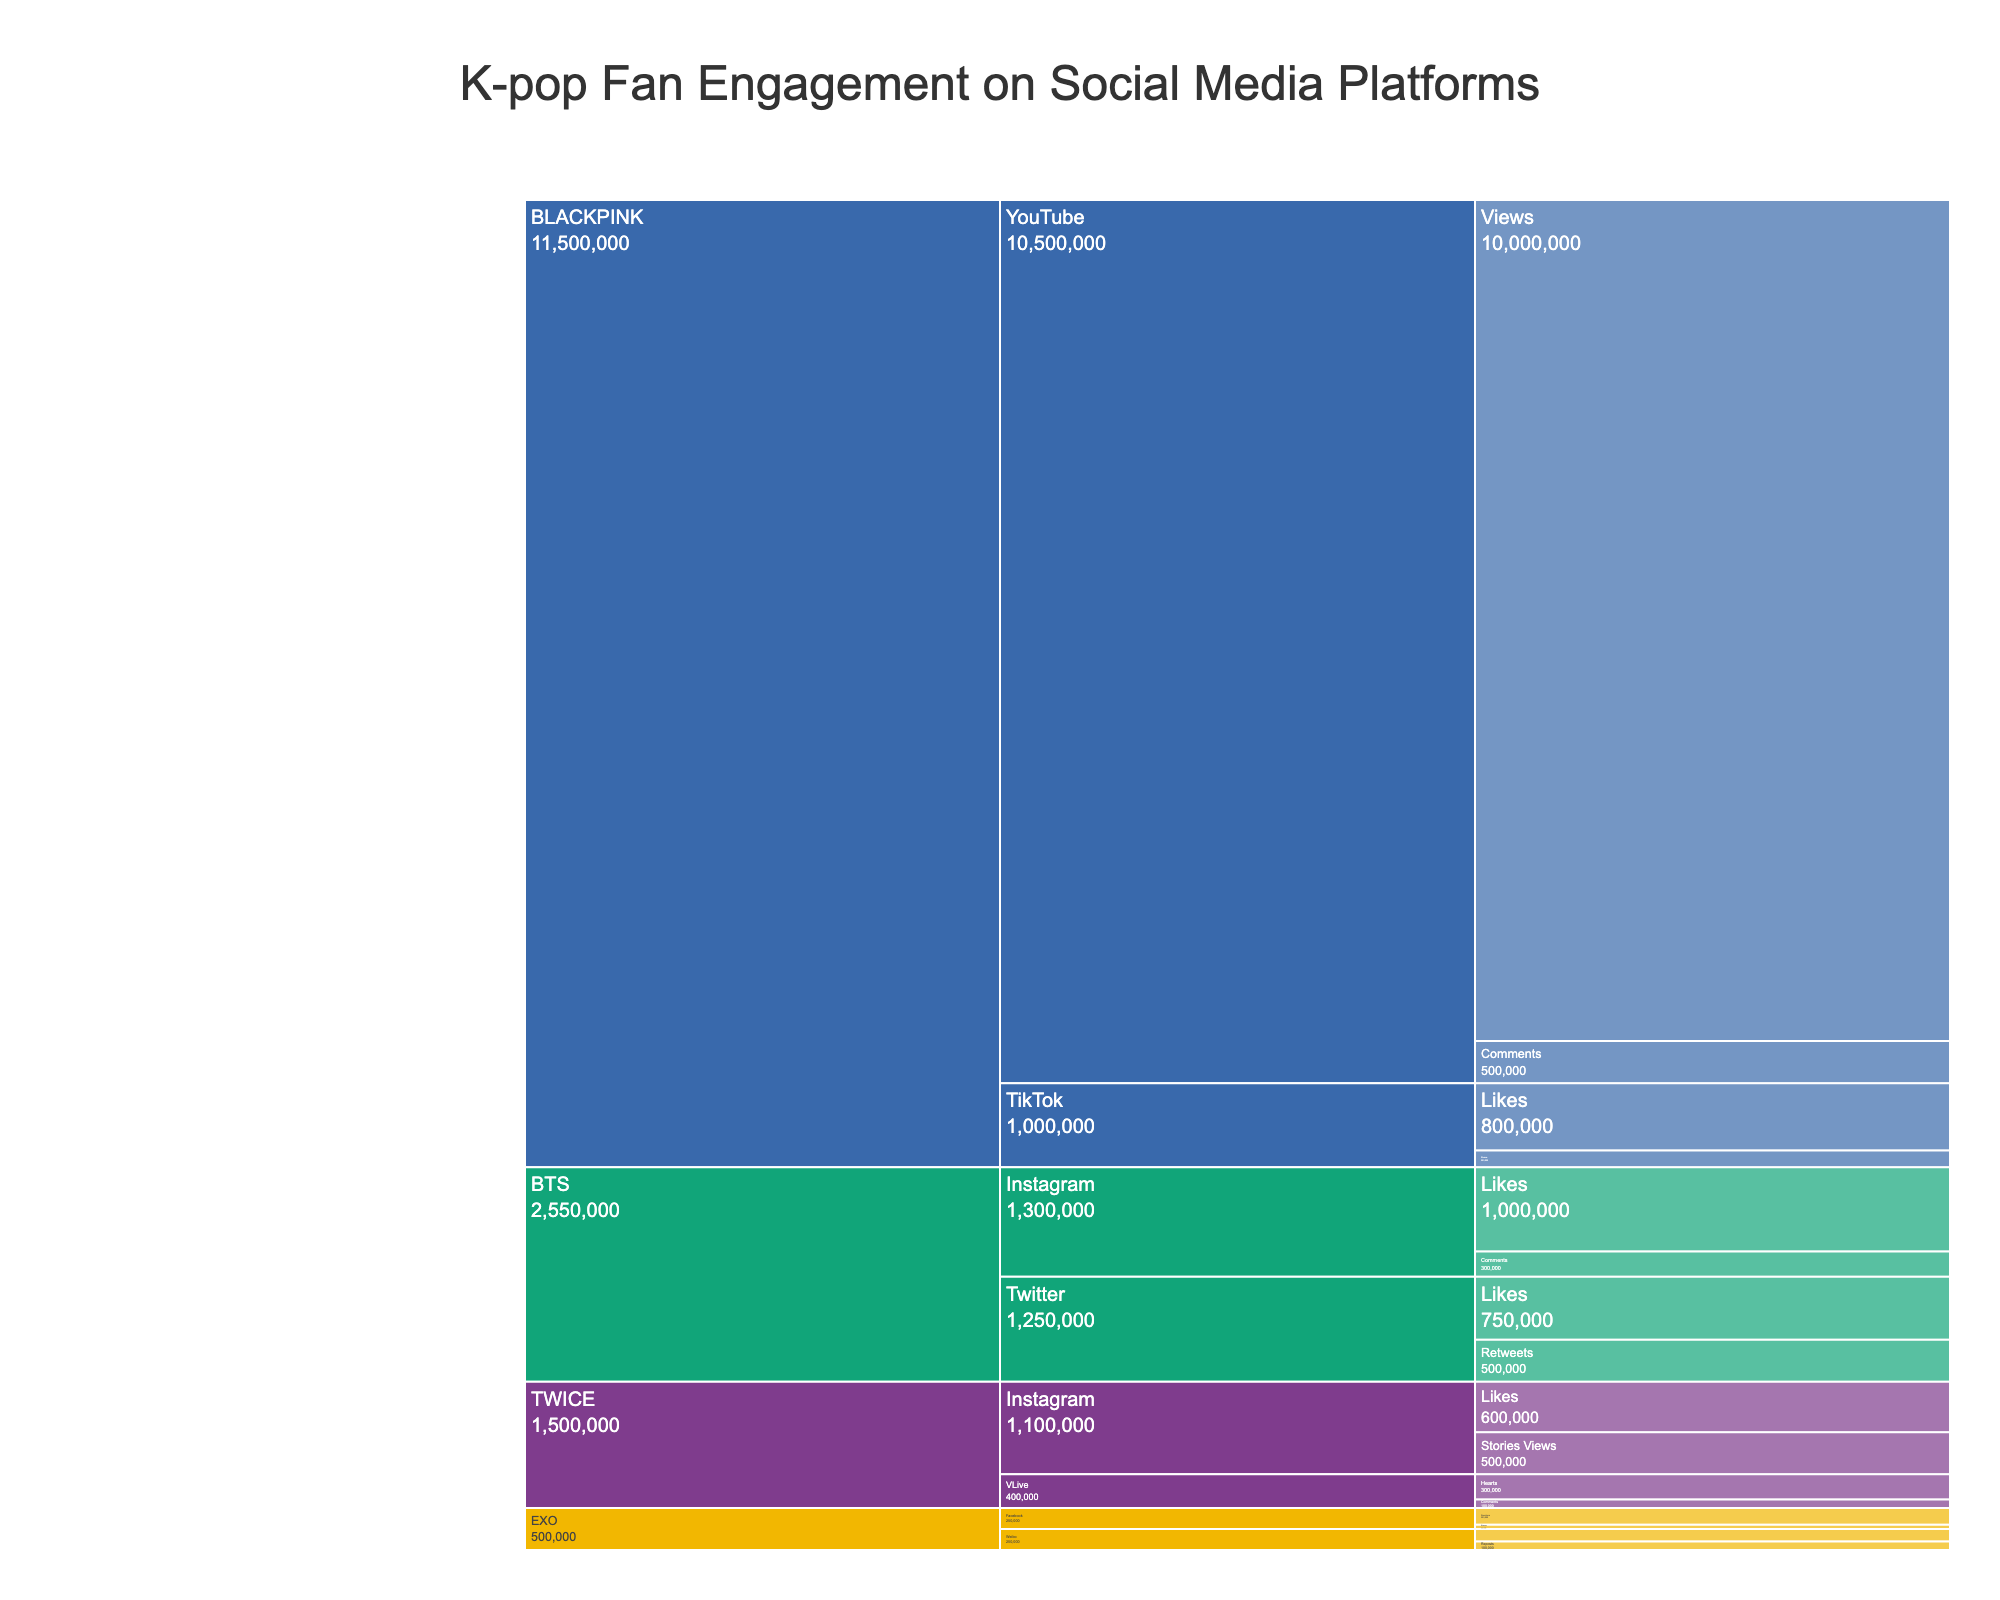How many interaction types are listed for BLACKPINK on YouTube? Look at the portion of the icicle chart corresponding to BLACKPINK and then focus on the YouTube section. Count the number of unique interaction types appearing within that section.
Answer: 2 Which platform has the highest engagement count for BTS? Examine the branches of the icicle chart that correspond to BTS. Compare the total engagement counts across each platform (Twitter, Instagram) to determine which has the highest sum.
Answer: Instagram What is the total engagement count for TWICE on Instagram? Navigate the chart to the section for TWICE under Instagram. Sum the engagement counts for all interaction types listed (Stories Views and Likes).
Answer: 1,100,000 Which K-pop group has the lowest engagement on Weibo? Identify the sections corresponding to each group active on Weibo by tracing the chart to find EXO. Compare the engagement counts for EXO (Reposts, Comments).
Answer: EXO What is the difference in engagement counts between BLACKPINK's Views on YouTube and BTS's Likes on Instagram? Look for the engagement counts for BLACKPINK's Views on YouTube and BTS's Likes on Instagram. Calculate the difference between these two values: 10,000,000 - 1,000,000.
Answer: 9,000,000 How does TWICE's engagement on VLive compare to EXO's engagement on Facebook in terms of total counts? Identify the VLive engagement counts for TWICE and the Facebook engagement counts for EXO. Calculate the total for each group on these platforms (300,000 + 100,000 for TWICE; 50,000 + 200,000 for EXO) and compare them.
Answer: TWICE has less total engagement What is the most common interaction type for BTS on Twitter? Refer to the section for BTS on Twitter and compare the engagement counts for Retweets and Likes. The interaction type with the higher count will be the most common one.
Answer: Likes Which interaction type has the highest engagement count overall in the chart? Scan the entire icicle chart for the interaction type with the highest individual engagement count. This can be found by comparing each count: BLACKPINK's YouTube Views would be the one.
Answer: Views How many platforms does TWICE engage on, and what are they? Identify each unique platform node within the branch of the icicle chart for TWICE. Count the total number of platforms and list their names.
Answer: 2 platforms: VLive, Instagram What is the ratio of BTS's Likes on Twitter to BLACKPINK's Comments on YouTube? Find the engagement counts for BTS's Likes on Twitter and BLACKPINK's Comments on YouTube. Calculate the ratio (750,000 / 500,000).
Answer: 1.5 